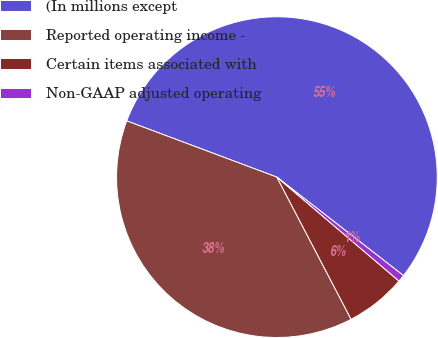<chart> <loc_0><loc_0><loc_500><loc_500><pie_chart><fcel>(In millions except<fcel>Reported operating income -<fcel>Certain items associated with<fcel>Non-GAAP adjusted operating<nl><fcel>54.82%<fcel>38.36%<fcel>6.12%<fcel>0.7%<nl></chart> 